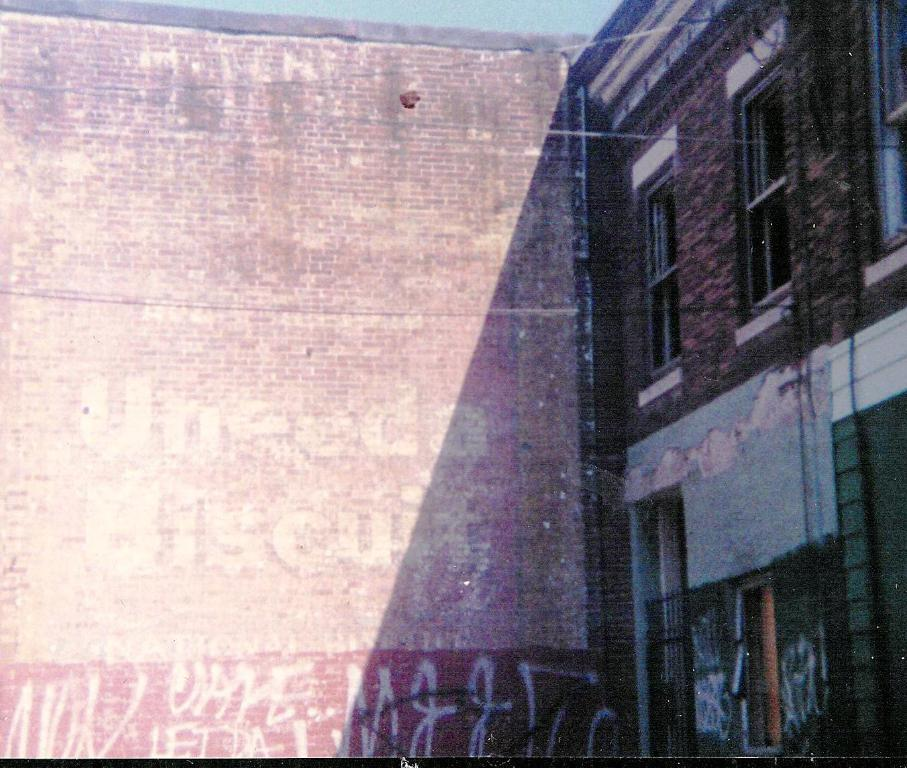What is written or depicted on the brick wall in the image? There is text on a brick wall in the image. What type of structure is visible in the image? There is a building in the image. What architectural feature can be seen on the building? There are windows on the building. What type of rice is being served with the fork in the image? There is no fork or rice present in the image; it only features text on a brick wall and a building with windows. Is there a glove visible on the windowsill in the image? There is no glove present in the image. 